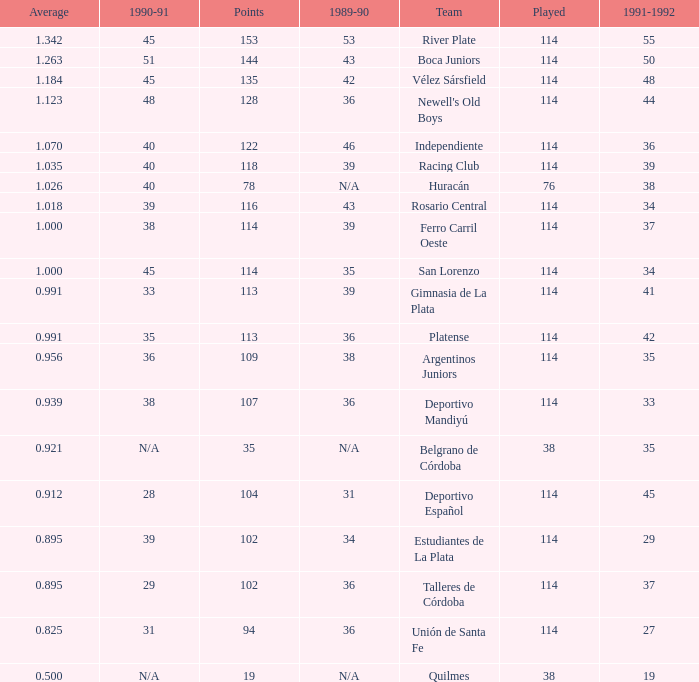How much 1991-1992 has a Team of gimnasia de la plata, and more than 113 points? 0.0. 